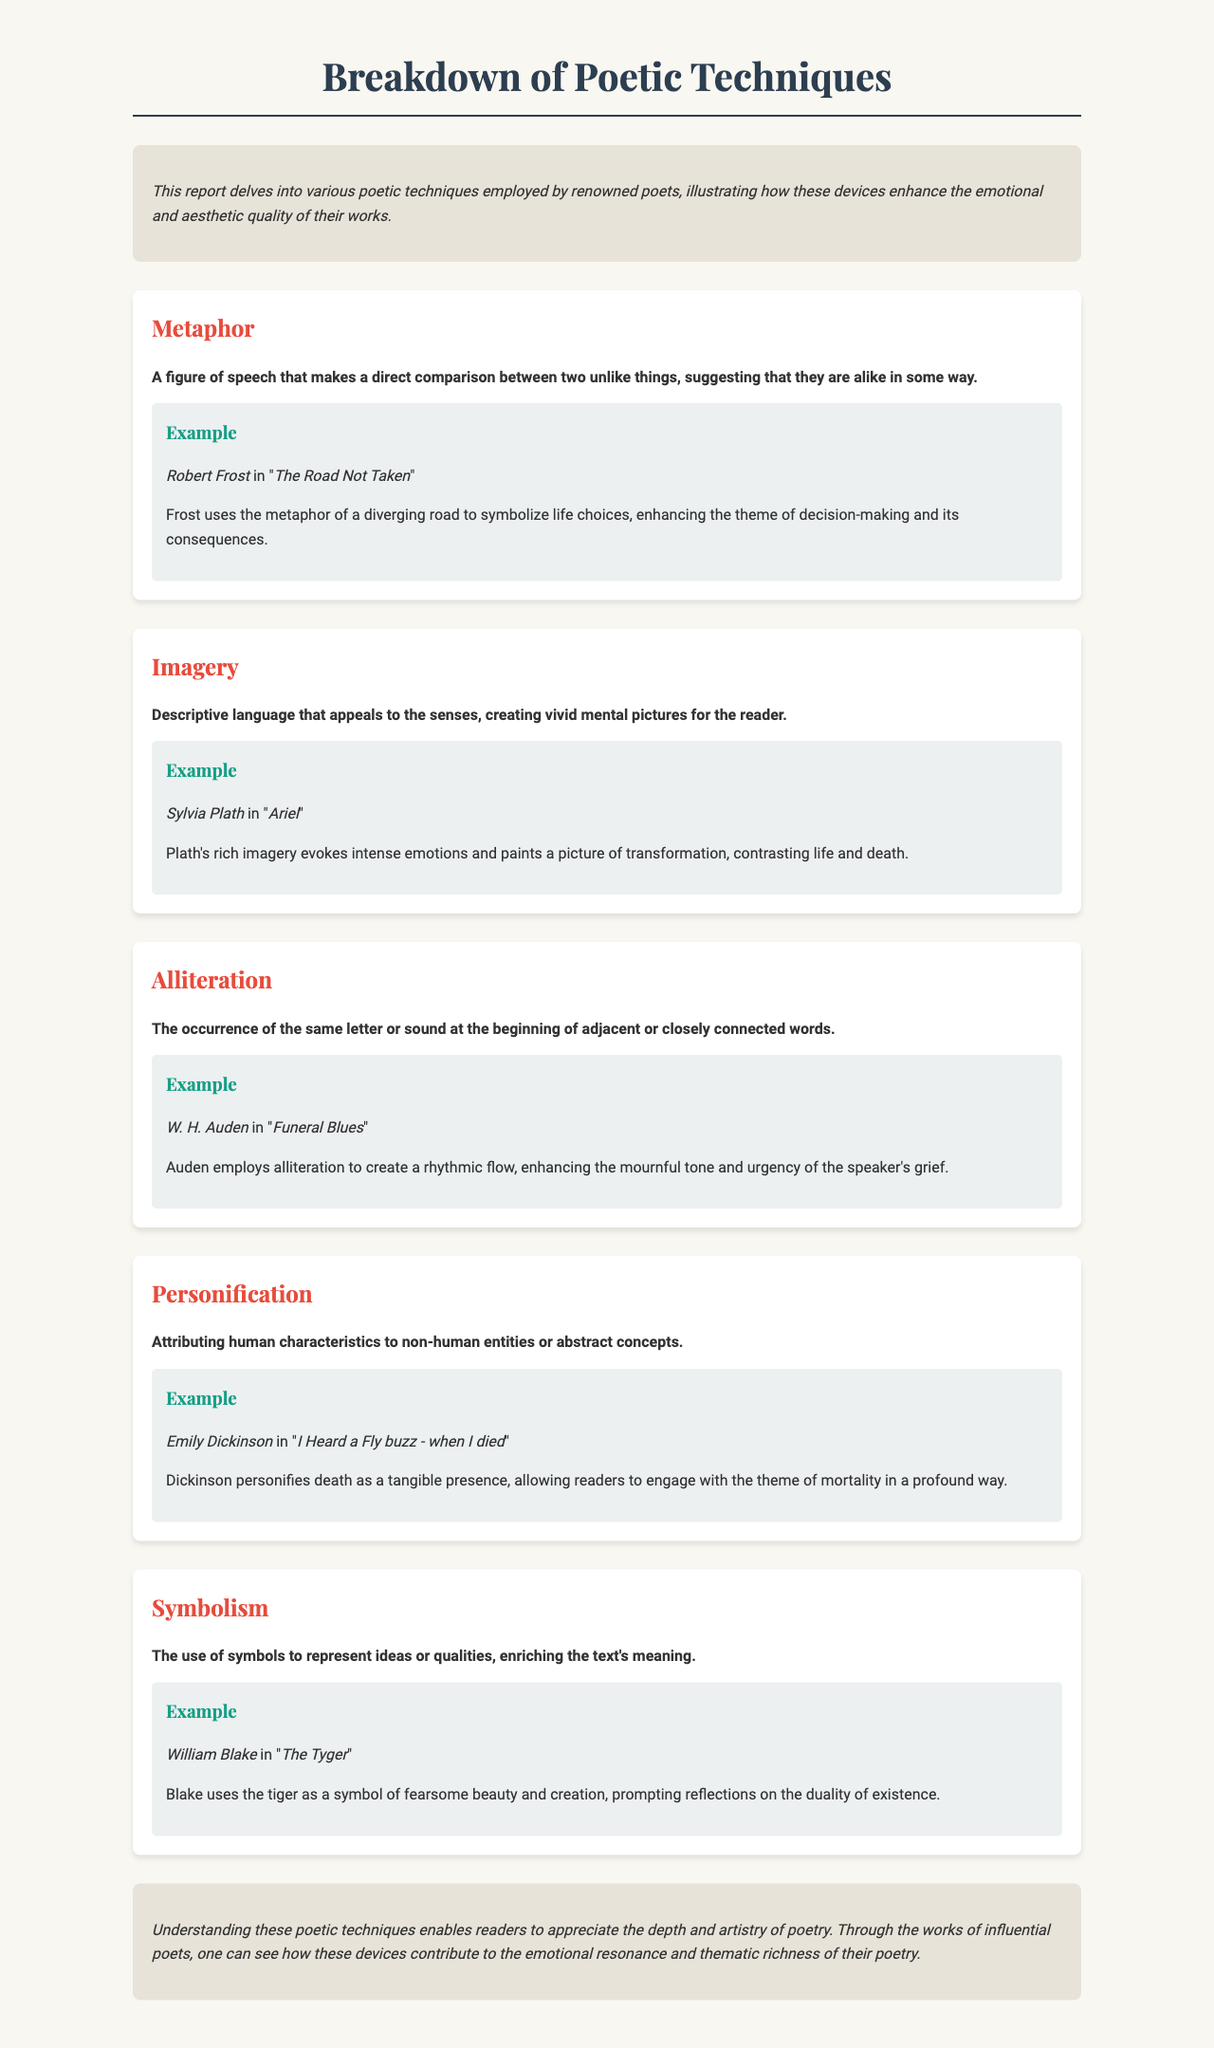What is the title of the report? The title of the report is provided at the top of the document, which summarizes its content on poetic techniques.
Answer: Breakdown of Poetic Techniques Who is the poet associated with the work "The Road Not Taken"? The document includes a specific example from the poet linked with the metaphor technique in the report.
Answer: Robert Frost What technique is defined as "descriptive language that appeals to the senses"? This definition specifically describes one of the poetic techniques examined in the document, highlighting its sensory appeal.
Answer: Imagery In which poem does Sylvia Plath use rich imagery? The document provides a specific example of imagery through the mention of a poet and their work.
Answer: Ariel What is the purpose of understanding poetic techniques according to the conclusion? The document emphasizes an overall understanding that enhances appreciation for the literary form and its elements.
Answer: Appreciate depth and artistry What is the analysis of W. H. Auden's use of alliteration? The analysis explains how alliteration contributes to a specific tone and feeling in the poem, linking it to the themed experience.
Answer: Enhancing mournful tone and urgency Which poetic technique involves attributing human characteristics to non-human entities? The report defines a specific technique that does this, demonstrating its function in poetry.
Answer: Personification How does Blake's symbolism in "The Tyger" prompt reflection? The document discusses a specific aspect of symbolism used in a poem, indicating its thematic depth.
Answer: Fearsome beauty and creation What is the emotional focus of Robert Frost's metaphor in his poem? The analysis reveals the central theme conveyed by the metaphor regarding personal choices.
Answer: Life choices 